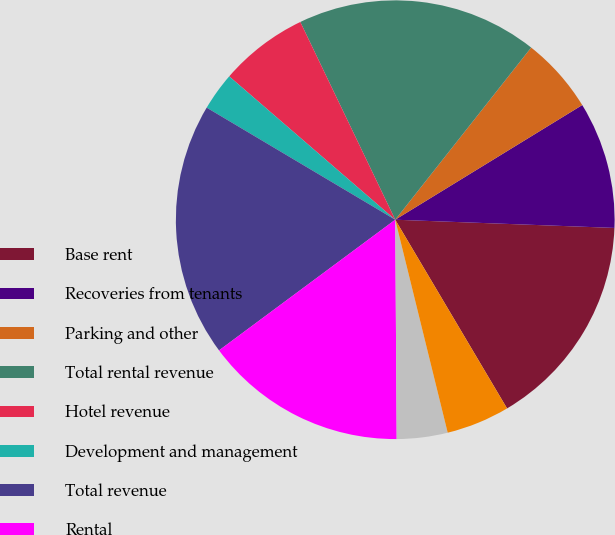Convert chart. <chart><loc_0><loc_0><loc_500><loc_500><pie_chart><fcel>Base rent<fcel>Recoveries from tenants<fcel>Parking and other<fcel>Total rental revenue<fcel>Hotel revenue<fcel>Development and management<fcel>Total revenue<fcel>Rental<fcel>Hotel<fcel>General and administrative<nl><fcel>15.89%<fcel>9.35%<fcel>5.61%<fcel>17.76%<fcel>6.54%<fcel>2.8%<fcel>18.69%<fcel>14.95%<fcel>3.74%<fcel>4.67%<nl></chart> 